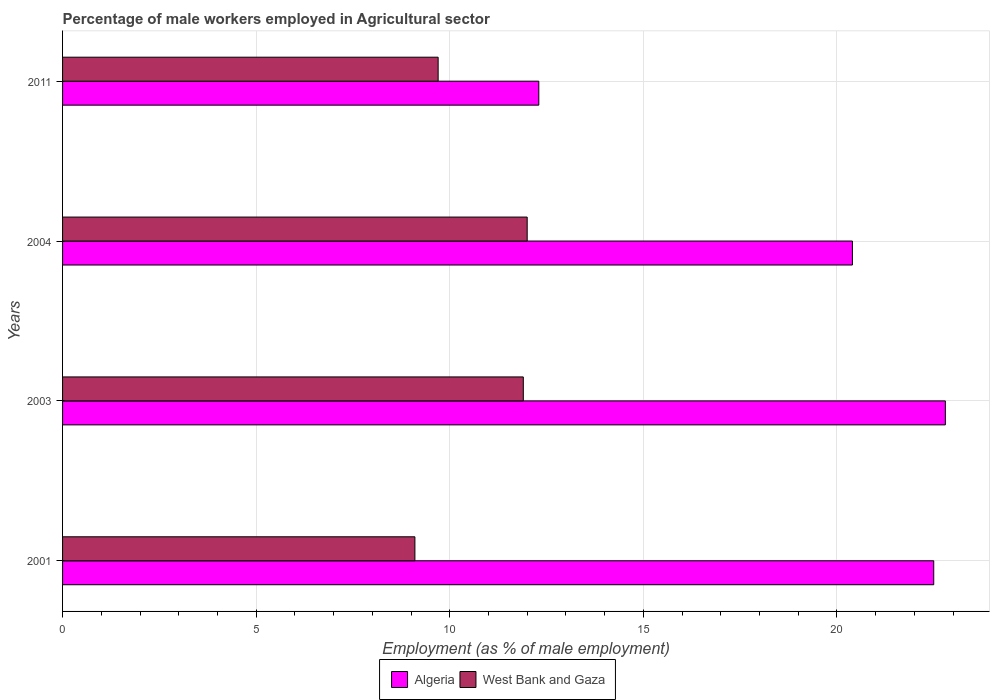How many groups of bars are there?
Keep it short and to the point. 4. What is the label of the 4th group of bars from the top?
Keep it short and to the point. 2001. What is the percentage of male workers employed in Agricultural sector in West Bank and Gaza in 2011?
Offer a terse response. 9.7. Across all years, what is the maximum percentage of male workers employed in Agricultural sector in Algeria?
Your response must be concise. 22.8. Across all years, what is the minimum percentage of male workers employed in Agricultural sector in West Bank and Gaza?
Keep it short and to the point. 9.1. In which year was the percentage of male workers employed in Agricultural sector in West Bank and Gaza maximum?
Offer a terse response. 2004. What is the total percentage of male workers employed in Agricultural sector in Algeria in the graph?
Keep it short and to the point. 78. What is the difference between the percentage of male workers employed in Agricultural sector in West Bank and Gaza in 2003 and that in 2004?
Give a very brief answer. -0.1. What is the difference between the percentage of male workers employed in Agricultural sector in Algeria in 2001 and the percentage of male workers employed in Agricultural sector in West Bank and Gaza in 2003?
Keep it short and to the point. 10.6. What is the average percentage of male workers employed in Agricultural sector in West Bank and Gaza per year?
Your answer should be compact. 10.67. In the year 2011, what is the difference between the percentage of male workers employed in Agricultural sector in West Bank and Gaza and percentage of male workers employed in Agricultural sector in Algeria?
Your answer should be compact. -2.6. What is the ratio of the percentage of male workers employed in Agricultural sector in West Bank and Gaza in 2001 to that in 2004?
Your answer should be very brief. 0.76. Is the percentage of male workers employed in Agricultural sector in Algeria in 2001 less than that in 2003?
Make the answer very short. Yes. Is the difference between the percentage of male workers employed in Agricultural sector in West Bank and Gaza in 2001 and 2011 greater than the difference between the percentage of male workers employed in Agricultural sector in Algeria in 2001 and 2011?
Make the answer very short. No. What is the difference between the highest and the second highest percentage of male workers employed in Agricultural sector in West Bank and Gaza?
Your response must be concise. 0.1. What is the difference between the highest and the lowest percentage of male workers employed in Agricultural sector in Algeria?
Give a very brief answer. 10.5. In how many years, is the percentage of male workers employed in Agricultural sector in West Bank and Gaza greater than the average percentage of male workers employed in Agricultural sector in West Bank and Gaza taken over all years?
Provide a short and direct response. 2. Is the sum of the percentage of male workers employed in Agricultural sector in Algeria in 2003 and 2011 greater than the maximum percentage of male workers employed in Agricultural sector in West Bank and Gaza across all years?
Ensure brevity in your answer.  Yes. What does the 2nd bar from the top in 2003 represents?
Offer a very short reply. Algeria. What does the 1st bar from the bottom in 2004 represents?
Make the answer very short. Algeria. How many bars are there?
Your answer should be compact. 8. Are the values on the major ticks of X-axis written in scientific E-notation?
Provide a short and direct response. No. Where does the legend appear in the graph?
Make the answer very short. Bottom center. How many legend labels are there?
Offer a terse response. 2. How are the legend labels stacked?
Your answer should be compact. Horizontal. What is the title of the graph?
Ensure brevity in your answer.  Percentage of male workers employed in Agricultural sector. What is the label or title of the X-axis?
Your answer should be very brief. Employment (as % of male employment). What is the label or title of the Y-axis?
Offer a terse response. Years. What is the Employment (as % of male employment) in Algeria in 2001?
Offer a very short reply. 22.5. What is the Employment (as % of male employment) in West Bank and Gaza in 2001?
Offer a very short reply. 9.1. What is the Employment (as % of male employment) of Algeria in 2003?
Ensure brevity in your answer.  22.8. What is the Employment (as % of male employment) of West Bank and Gaza in 2003?
Provide a succinct answer. 11.9. What is the Employment (as % of male employment) of Algeria in 2004?
Make the answer very short. 20.4. What is the Employment (as % of male employment) in Algeria in 2011?
Keep it short and to the point. 12.3. What is the Employment (as % of male employment) in West Bank and Gaza in 2011?
Offer a terse response. 9.7. Across all years, what is the maximum Employment (as % of male employment) of Algeria?
Provide a short and direct response. 22.8. Across all years, what is the minimum Employment (as % of male employment) in Algeria?
Ensure brevity in your answer.  12.3. Across all years, what is the minimum Employment (as % of male employment) of West Bank and Gaza?
Your response must be concise. 9.1. What is the total Employment (as % of male employment) of West Bank and Gaza in the graph?
Offer a very short reply. 42.7. What is the difference between the Employment (as % of male employment) in Algeria in 2001 and that in 2003?
Your response must be concise. -0.3. What is the difference between the Employment (as % of male employment) of Algeria in 2001 and that in 2004?
Your answer should be compact. 2.1. What is the difference between the Employment (as % of male employment) of Algeria in 2003 and that in 2004?
Offer a terse response. 2.4. What is the difference between the Employment (as % of male employment) in West Bank and Gaza in 2003 and that in 2004?
Make the answer very short. -0.1. What is the difference between the Employment (as % of male employment) of West Bank and Gaza in 2004 and that in 2011?
Offer a terse response. 2.3. What is the difference between the Employment (as % of male employment) of Algeria in 2001 and the Employment (as % of male employment) of West Bank and Gaza in 2011?
Offer a terse response. 12.8. What is the difference between the Employment (as % of male employment) of Algeria in 2004 and the Employment (as % of male employment) of West Bank and Gaza in 2011?
Offer a terse response. 10.7. What is the average Employment (as % of male employment) of Algeria per year?
Your answer should be compact. 19.5. What is the average Employment (as % of male employment) in West Bank and Gaza per year?
Offer a very short reply. 10.68. In the year 2001, what is the difference between the Employment (as % of male employment) of Algeria and Employment (as % of male employment) of West Bank and Gaza?
Provide a short and direct response. 13.4. In the year 2003, what is the difference between the Employment (as % of male employment) of Algeria and Employment (as % of male employment) of West Bank and Gaza?
Provide a succinct answer. 10.9. What is the ratio of the Employment (as % of male employment) in West Bank and Gaza in 2001 to that in 2003?
Your answer should be compact. 0.76. What is the ratio of the Employment (as % of male employment) of Algeria in 2001 to that in 2004?
Provide a succinct answer. 1.1. What is the ratio of the Employment (as % of male employment) in West Bank and Gaza in 2001 to that in 2004?
Your answer should be compact. 0.76. What is the ratio of the Employment (as % of male employment) in Algeria in 2001 to that in 2011?
Offer a terse response. 1.83. What is the ratio of the Employment (as % of male employment) in West Bank and Gaza in 2001 to that in 2011?
Your answer should be compact. 0.94. What is the ratio of the Employment (as % of male employment) in Algeria in 2003 to that in 2004?
Your answer should be very brief. 1.12. What is the ratio of the Employment (as % of male employment) in Algeria in 2003 to that in 2011?
Your answer should be compact. 1.85. What is the ratio of the Employment (as % of male employment) in West Bank and Gaza in 2003 to that in 2011?
Your answer should be compact. 1.23. What is the ratio of the Employment (as % of male employment) of Algeria in 2004 to that in 2011?
Provide a succinct answer. 1.66. What is the ratio of the Employment (as % of male employment) of West Bank and Gaza in 2004 to that in 2011?
Your answer should be compact. 1.24. What is the difference between the highest and the second highest Employment (as % of male employment) of West Bank and Gaza?
Offer a very short reply. 0.1. 